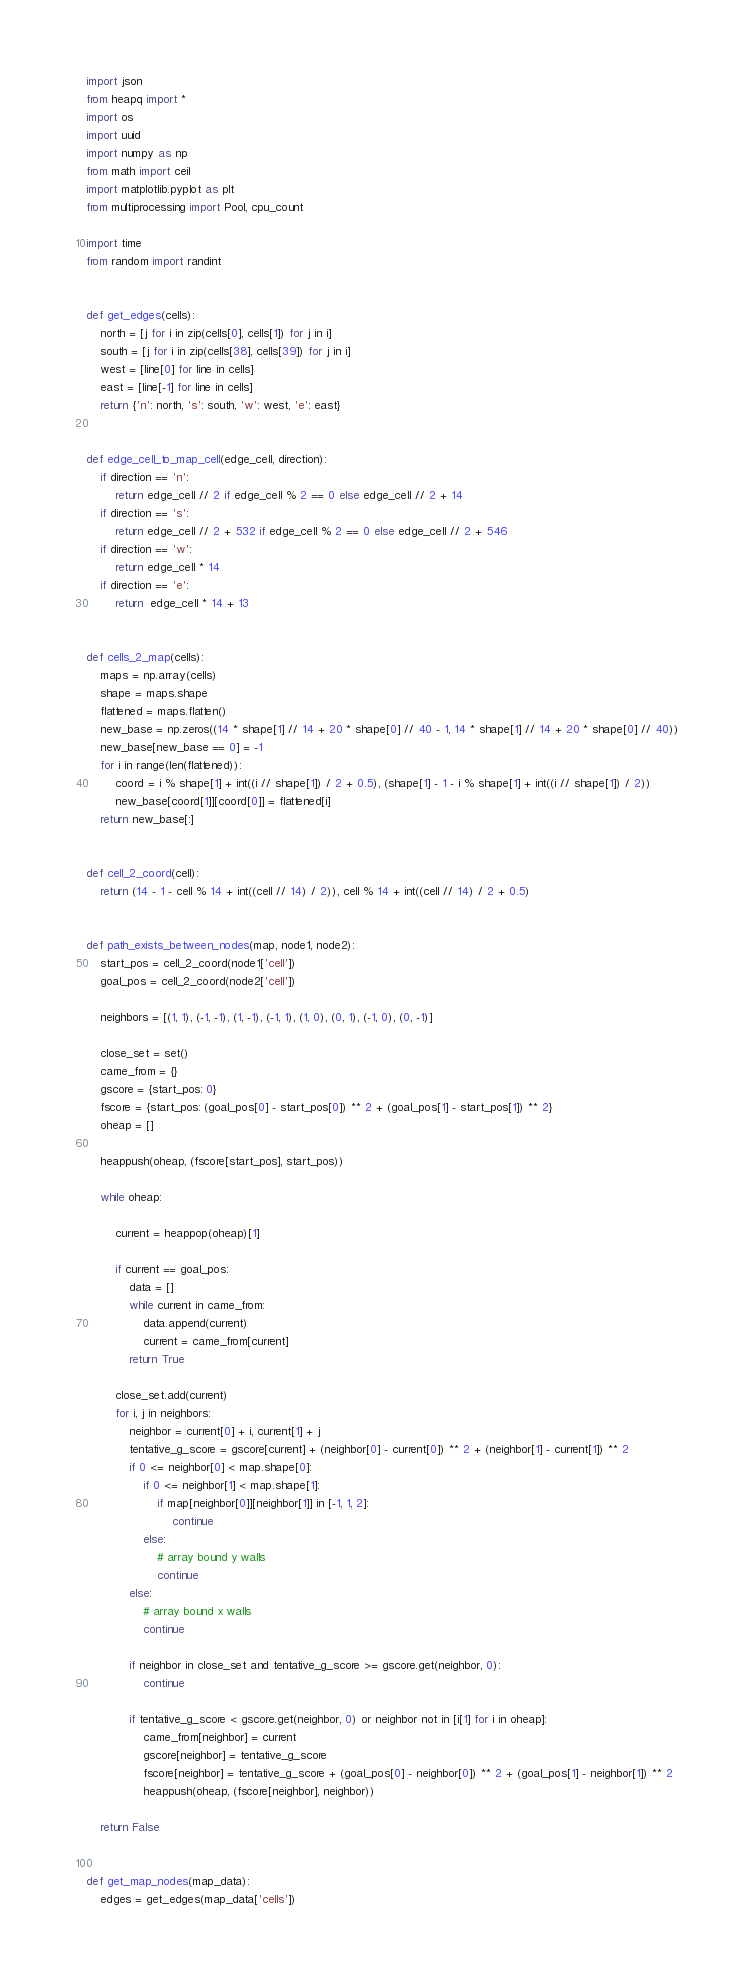Convert code to text. <code><loc_0><loc_0><loc_500><loc_500><_Python_>import json
from heapq import *
import os
import uuid
import numpy as np
from math import ceil
import matplotlib.pyplot as plt
from multiprocessing import Pool, cpu_count

import time
from random import randint


def get_edges(cells):
    north = [j for i in zip(cells[0], cells[1]) for j in i]
    south = [j for i in zip(cells[38], cells[39]) for j in i]
    west = [line[0] for line in cells]
    east = [line[-1] for line in cells]
    return {'n': north, 's': south, 'w': west, 'e': east}


def edge_cell_to_map_cell(edge_cell, direction):
    if direction == 'n':
        return edge_cell // 2 if edge_cell % 2 == 0 else edge_cell // 2 + 14
    if direction == 's':
        return edge_cell // 2 + 532 if edge_cell % 2 == 0 else edge_cell // 2 + 546
    if direction == 'w':
        return edge_cell * 14
    if direction == 'e':
        return  edge_cell * 14 + 13


def cells_2_map(cells):
    maps = np.array(cells)
    shape = maps.shape
    flattened = maps.flatten()
    new_base = np.zeros((14 * shape[1] // 14 + 20 * shape[0] // 40 - 1, 14 * shape[1] // 14 + 20 * shape[0] // 40))
    new_base[new_base == 0] = -1
    for i in range(len(flattened)):
        coord = i % shape[1] + int((i // shape[1]) / 2 + 0.5), (shape[1] - 1 - i % shape[1] + int((i // shape[1]) / 2))
        new_base[coord[1]][coord[0]] = flattened[i]
    return new_base[:]


def cell_2_coord(cell):
    return (14 - 1 - cell % 14 + int((cell // 14) / 2)), cell % 14 + int((cell // 14) / 2 + 0.5)


def path_exists_between_nodes(map, node1, node2):
    start_pos = cell_2_coord(node1['cell'])
    goal_pos = cell_2_coord(node2['cell'])

    neighbors = [(1, 1), (-1, -1), (1, -1), (-1, 1), (1, 0), (0, 1), (-1, 0), (0, -1)]

    close_set = set()
    came_from = {}
    gscore = {start_pos: 0}
    fscore = {start_pos: (goal_pos[0] - start_pos[0]) ** 2 + (goal_pos[1] - start_pos[1]) ** 2}
    oheap = []

    heappush(oheap, (fscore[start_pos], start_pos))

    while oheap:

        current = heappop(oheap)[1]

        if current == goal_pos:
            data = []
            while current in came_from:
                data.append(current)
                current = came_from[current]
            return True

        close_set.add(current)
        for i, j in neighbors:
            neighbor = current[0] + i, current[1] + j
            tentative_g_score = gscore[current] + (neighbor[0] - current[0]) ** 2 + (neighbor[1] - current[1]) ** 2
            if 0 <= neighbor[0] < map.shape[0]:
                if 0 <= neighbor[1] < map.shape[1]:
                    if map[neighbor[0]][neighbor[1]] in [-1, 1, 2]:
                        continue
                else:
                    # array bound y walls
                    continue
            else:
                # array bound x walls
                continue

            if neighbor in close_set and tentative_g_score >= gscore.get(neighbor, 0):
                continue

            if tentative_g_score < gscore.get(neighbor, 0) or neighbor not in [i[1] for i in oheap]:
                came_from[neighbor] = current
                gscore[neighbor] = tentative_g_score
                fscore[neighbor] = tentative_g_score + (goal_pos[0] - neighbor[0]) ** 2 + (goal_pos[1] - neighbor[1]) ** 2
                heappush(oheap, (fscore[neighbor], neighbor))

    return False


def get_map_nodes(map_data):
    edges = get_edges(map_data['cells'])</code> 